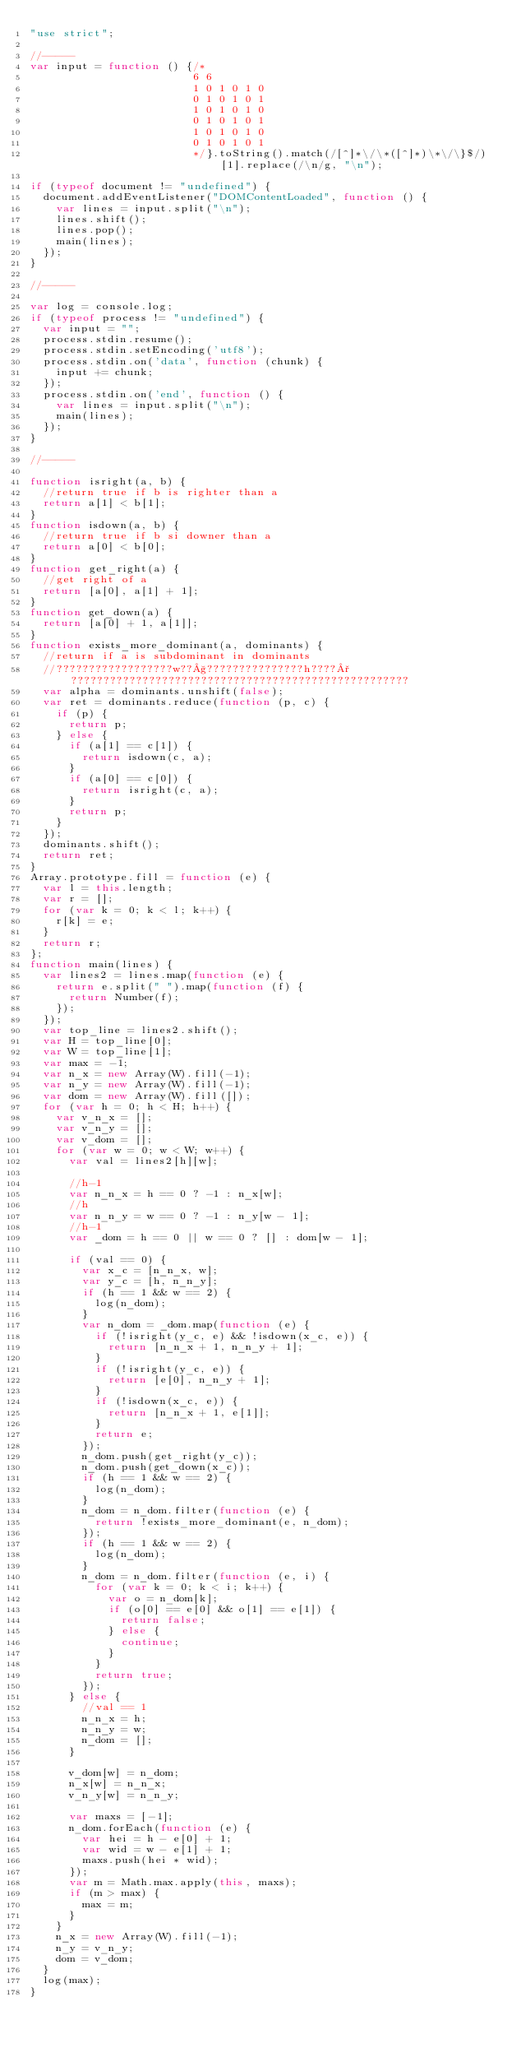Convert code to text. <code><loc_0><loc_0><loc_500><loc_500><_JavaScript_>"use strict";

//-----
var input = function () {/*
                         6 6
                         1 0 1 0 1 0
                         0 1 0 1 0 1
                         1 0 1 0 1 0
                         0 1 0 1 0 1
                         1 0 1 0 1 0
                         0 1 0 1 0 1
                         */}.toString().match(/[^]*\/\*([^]*)\*\/\}$/)[1].replace(/\n/g, "\n");

if (typeof document != "undefined") {
	document.addEventListener("DOMContentLoaded", function () {
		var lines = input.split("\n");
		lines.shift();
		lines.pop();
		main(lines);
	});
}

//-----

var log = console.log;
if (typeof process != "undefined") {
	var input = "";
	process.stdin.resume();
	process.stdin.setEncoding('utf8');
	process.stdin.on('data', function (chunk) {
		input += chunk;
	});
	process.stdin.on('end', function () {
		var lines = input.split("\n");
		main(lines);
	});
}

//-----

function isright(a, b) {
	//return true if b is righter than a
	return a[1] < b[1];
}
function isdown(a, b) {
	//return true if b si downer than a
	return a[0] < b[0];
}
function get_right(a) {
	//get right of a
	return [a[0], a[1] + 1];
}
function get_down(a) {
	return [a[0] + 1, a[1]];
}
function exists_more_dominant(a, dominants) {
	//return if a is subdominant in dominants
	//??????????????????w??§???????????????h????°????????????????????????????????????????????????????
	var alpha = dominants.unshift(false);
	var ret = dominants.reduce(function (p, c) {
		if (p) {
			return p;
		} else {
			if (a[1] == c[1]) {
				return isdown(c, a);
			}
			if (a[0] == c[0]) {
				return isright(c, a);
			}
			return p;
		}
	});
	dominants.shift();
	return ret;
}
Array.prototype.fill = function (e) {
	var l = this.length;
	var r = [];
	for (var k = 0; k < l; k++) {
		r[k] = e;
	}
	return r;
};
function main(lines) {
	var lines2 = lines.map(function (e) {
		return e.split(" ").map(function (f) {
			return Number(f);
		});
	});
	var top_line = lines2.shift();
	var H = top_line[0];
	var W = top_line[1];
	var max = -1;
	var n_x = new Array(W).fill(-1);
	var n_y = new Array(W).fill(-1);
	var dom = new Array(W).fill([]);
	for (var h = 0; h < H; h++) {
		var v_n_x = [];
		var v_n_y = [];
		var v_dom = [];
		for (var w = 0; w < W; w++) {
			var val = lines2[h][w];

			//h-1
			var n_n_x = h == 0 ? -1 : n_x[w];
			//h
			var n_n_y = w == 0 ? -1 : n_y[w - 1];
			//h-1
			var _dom = h == 0 || w == 0 ? [] : dom[w - 1];

			if (val == 0) {
				var x_c = [n_n_x, w];
				var y_c = [h, n_n_y];
				if (h == 1 && w == 2) {
					log(n_dom);
				}
				var n_dom = _dom.map(function (e) {
					if (!isright(y_c, e) && !isdown(x_c, e)) {
						return [n_n_x + 1, n_n_y + 1];
					}
					if (!isright(y_c, e)) {
						return [e[0], n_n_y + 1];
					}
					if (!isdown(x_c, e)) {
						return [n_n_x + 1, e[1]];
					}
					return e;
				});
				n_dom.push(get_right(y_c));
				n_dom.push(get_down(x_c));
				if (h == 1 && w == 2) {
					log(n_dom);
				}
				n_dom = n_dom.filter(function (e) {
					return !exists_more_dominant(e, n_dom);
				});
				if (h == 1 && w == 2) {
					log(n_dom);
				}
				n_dom = n_dom.filter(function (e, i) {
					for (var k = 0; k < i; k++) {
						var o = n_dom[k];
						if (o[0] == e[0] && o[1] == e[1]) {
							return false;
						} else {
							continue;
						}
					}
					return true;
				});
			} else {
				//val == 1
				n_n_x = h;
				n_n_y = w;
				n_dom = [];
			}

			v_dom[w] = n_dom;
			n_x[w] = n_n_x;
			v_n_y[w] = n_n_y;

			var maxs = [-1];
			n_dom.forEach(function (e) {
				var hei = h - e[0] + 1;
				var wid = w - e[1] + 1;
				maxs.push(hei * wid);
			});
			var m = Math.max.apply(this, maxs);
			if (m > max) {
				max = m;
			}
		}
		n_x = new Array(W).fill(-1);
		n_y = v_n_y;
		dom = v_dom;
	}
	log(max);
}</code> 